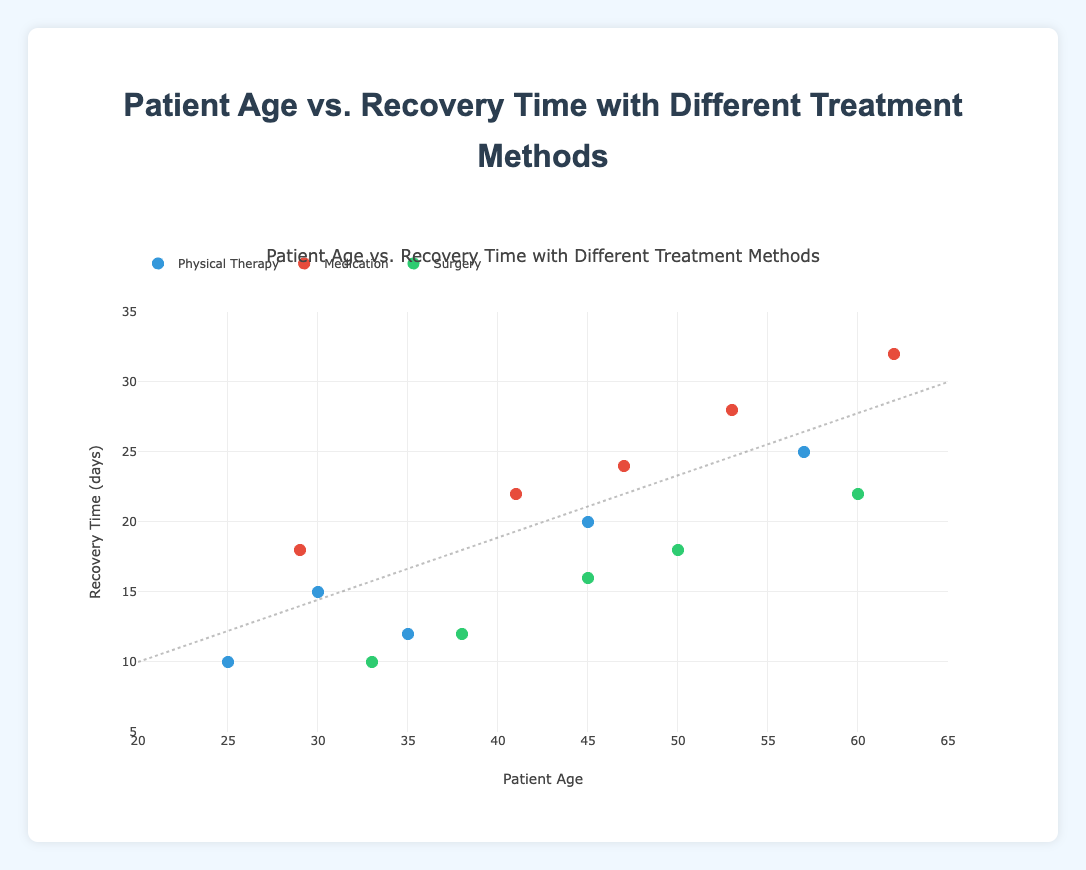What is the title of the chart? The title of the chart is displayed at the top. It reads "Patient Age vs. Recovery Time with Different Treatment Methods."
Answer: Patient Age vs. Recovery Time with Different Treatment Methods What are the x-axis and y-axis labels in the chart? The x-axis label is "Patient Age," and the y-axis label is "Recovery Time (days)."
Answer: Patient Age, Recovery Time (days) How many data points represent the "Surgery" treatment method? Identify the number of markers corresponding to the "Surgery" treatment method, which should be green. Count these markers.
Answer: 5 What is the general trend indicated by the trend line in the figure? The trend line indicates the relationship between patient age and recovery time. The line runs from lower left to the upper right, suggesting that recovery time increases with patient age.
Answer: Recovery time increases with patient age Which treatment method has the highest recovery time, and what is it? Check the markers for each treatment method to find the highest recovery time. The red marker for the "Medication" method reaches the highest point on the y-axis.
Answer: Medication, 32 days What is the average recovery time for patients undergoing "Medication" treatment? For "Medication" treatment: (18 + 22 + 28 + 24 + 32) = 124. There are 5 patients, so the average recovery time is 124 / 5.
Answer: 24.8 days Compare the recovery time for a 45-year-old patient using "Physical Therapy" and "Medication". Which method has a shorter recovery time? Find the recovery times for "Physical Therapy" and "Medication" for patients aged 45. "Physical Therapy" is 20 days, and "Medication" is 24 days.
Answer: Physical Therapy has a shorter recovery time (20 days vs. 24 days) Is there a visible outlier in the "Physical Therapy" recovery times? What is it? Look at the scatter plot for "Physical Therapy" recovery times (blue markers). The value 25 days is significantly higher than others in this group.
Answer: 25 days What is the recovery time for a patient aged 33 using "Surgery"? Locate the point in the scatter plot for "Surgery" (green markers) at age 33. The corresponding y-value indicates the recovery time.
Answer: 10 days 